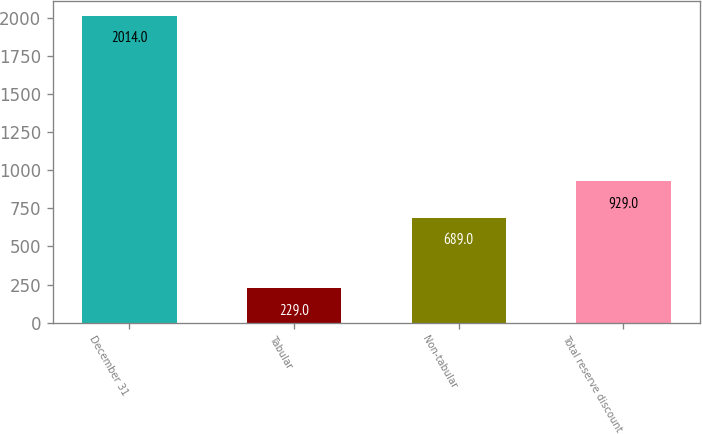<chart> <loc_0><loc_0><loc_500><loc_500><bar_chart><fcel>December 31<fcel>Tabular<fcel>Non-tabular<fcel>Total reserve discount<nl><fcel>2014<fcel>229<fcel>689<fcel>929<nl></chart> 